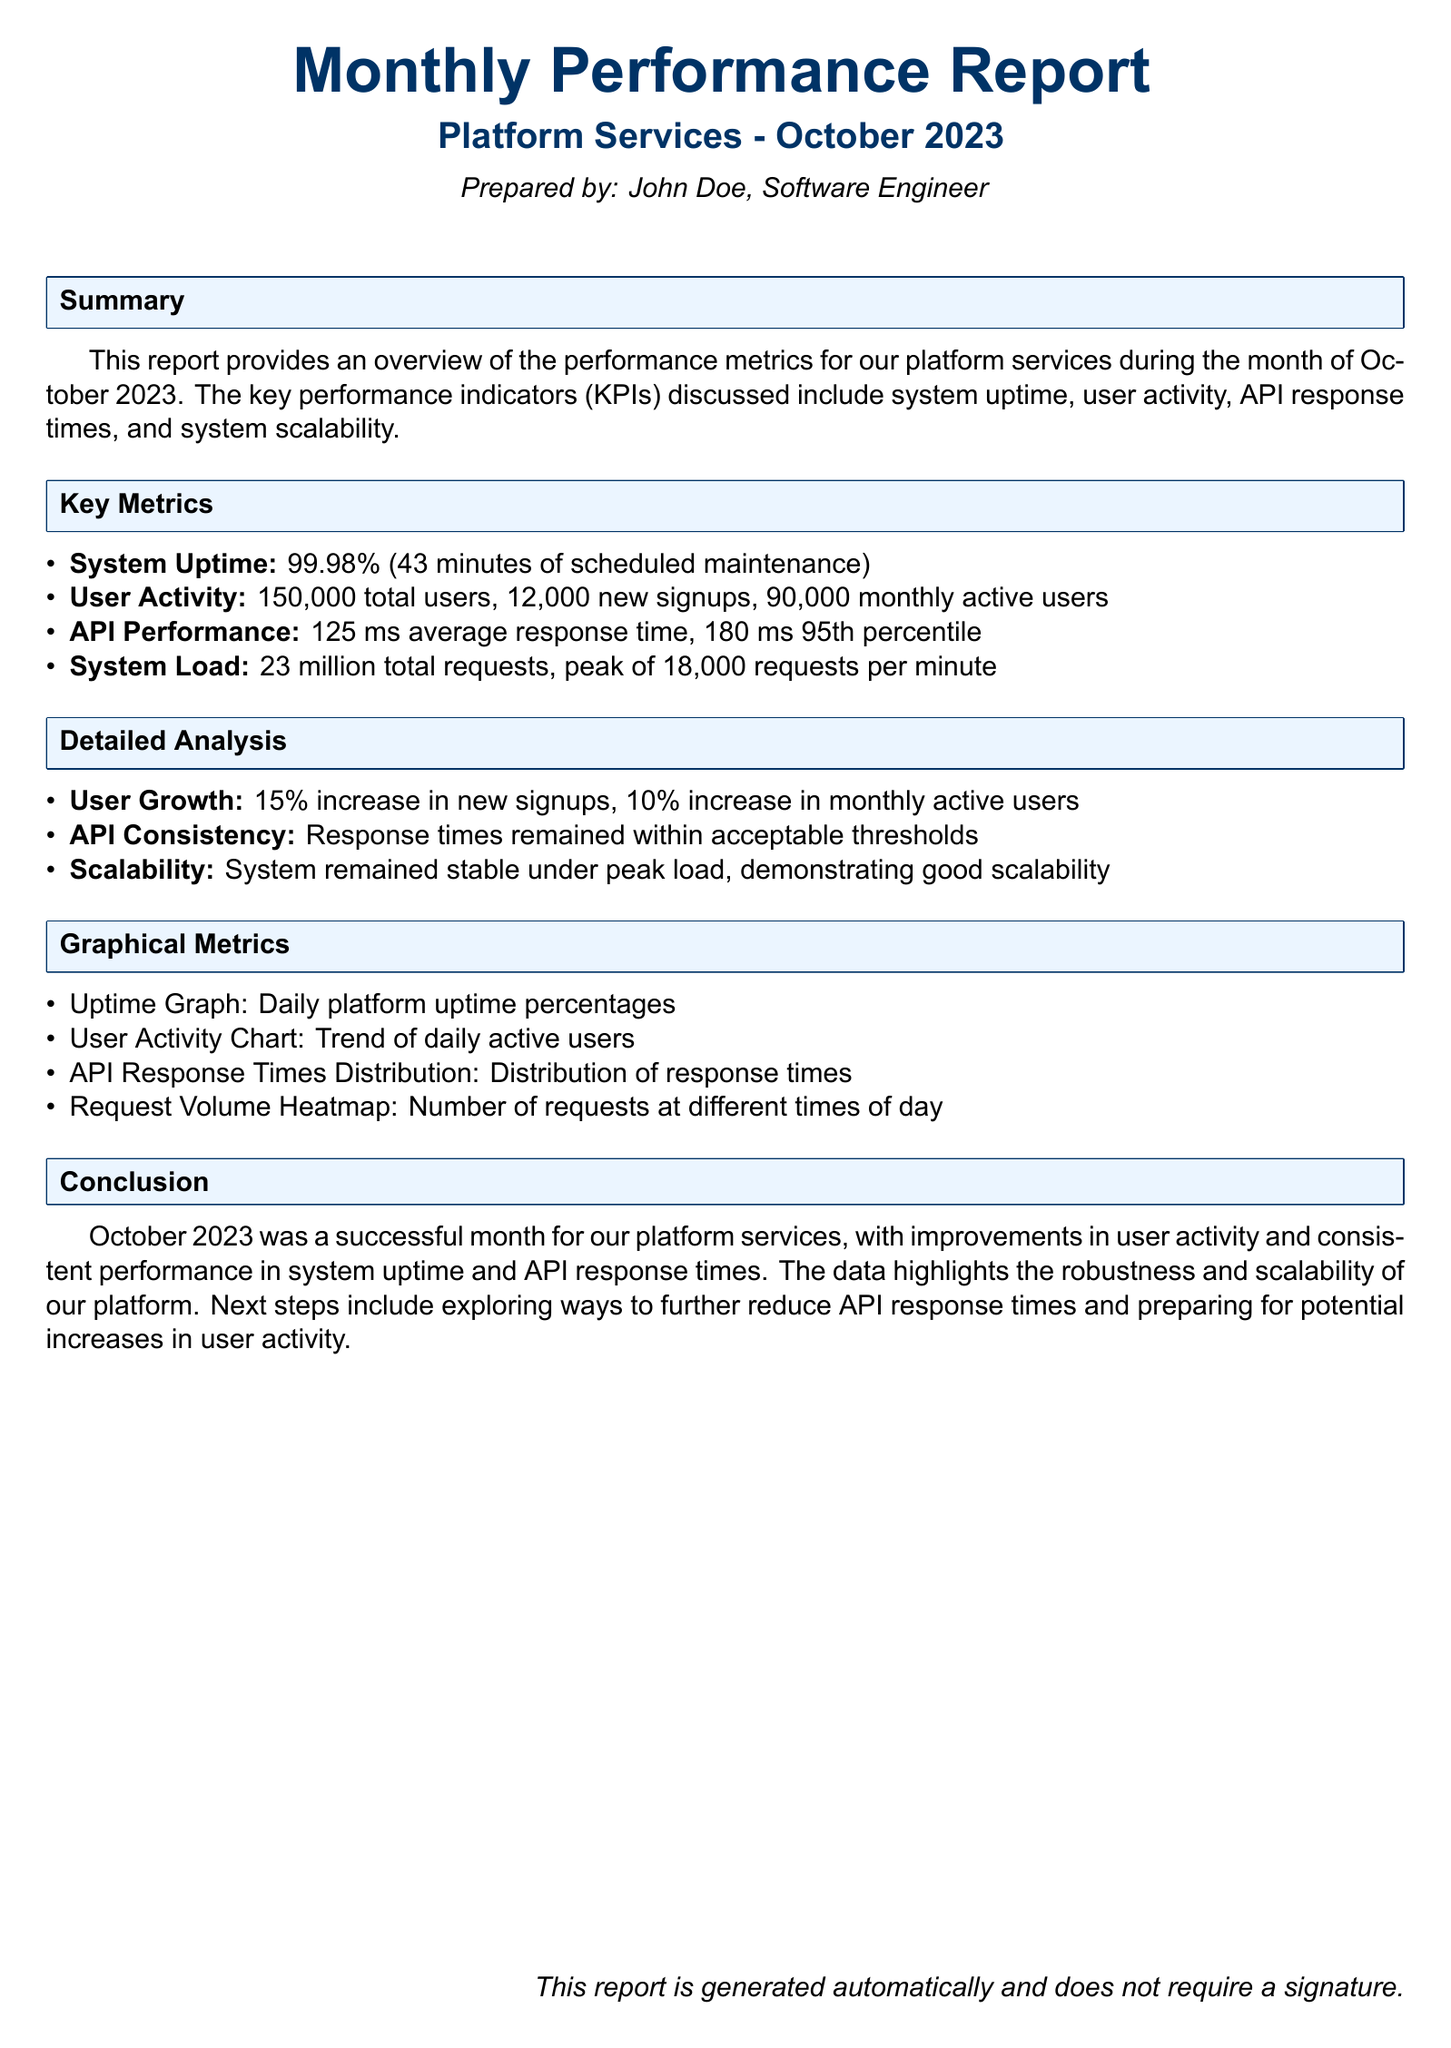What is the average response time for the API? The average response time for the API is a key performance indicator mentioned in the report.
Answer: 125 ms How many new signups were there in October 2023? The total number of new signups for the month is specified under user activity.
Answer: 12,000 What percentage of system uptime was achieved? System uptime is provided as a performance metric in the document.
Answer: 99.98% How much was the increase in new signups? The report highlights a specific percentage increase in new signups, providing insight into user growth.
Answer: 15% What was the peak system load in requests per minute? The report includes metrics related to system load, indicating peak performance levels.
Answer: 18,000 requests per minute What time frame does the report cover? The report mentions the month for which the performance metrics are being summarized.
Answer: October 2023 What is the total number of monthly active users? The report includes data on user activity, specifically indicating monthly active users.
Answer: 90,000 What type of graph is included in the graphical metrics section? The graphical metrics section outlines the types of data visualizations present in the report.
Answer: Uptime Graph What will be the next steps as suggested in the report? The conclusion section summarizes the outcomes and indicates future actions to be considered.
Answer: Reducing API response times 